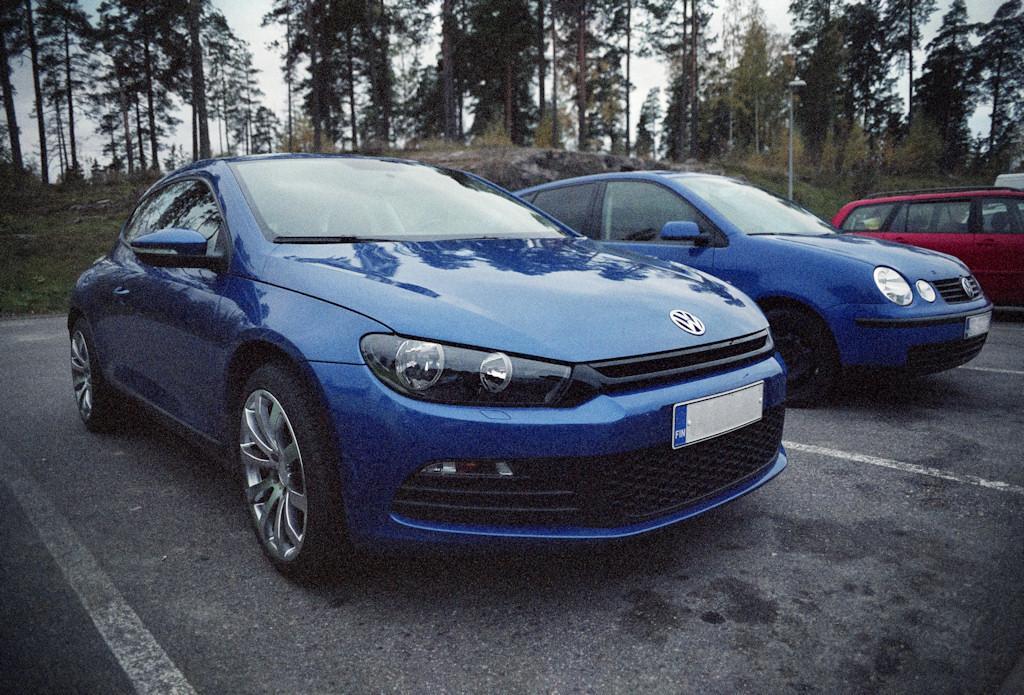How would you summarize this image in a sentence or two? In this image we can see the cars on the road. And we can see the lights. And we can see the trees. And we can see the sky. 